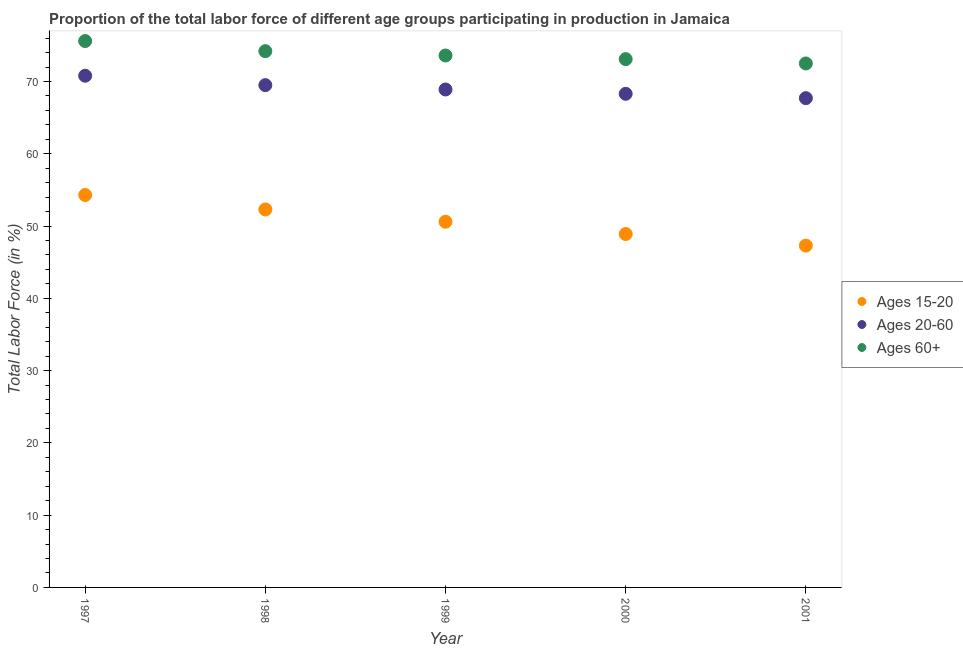How many different coloured dotlines are there?
Your answer should be compact. 3. Is the number of dotlines equal to the number of legend labels?
Offer a terse response. Yes. What is the percentage of labor force within the age group 20-60 in 1998?
Ensure brevity in your answer.  69.5. Across all years, what is the maximum percentage of labor force within the age group 15-20?
Keep it short and to the point. 54.3. Across all years, what is the minimum percentage of labor force within the age group 20-60?
Give a very brief answer. 67.7. In which year was the percentage of labor force within the age group 20-60 minimum?
Give a very brief answer. 2001. What is the total percentage of labor force within the age group 15-20 in the graph?
Your answer should be very brief. 253.4. What is the difference between the percentage of labor force within the age group 20-60 in 1997 and that in 2001?
Keep it short and to the point. 3.1. What is the difference between the percentage of labor force above age 60 in 1999 and the percentage of labor force within the age group 20-60 in 2000?
Give a very brief answer. 5.3. What is the average percentage of labor force within the age group 15-20 per year?
Give a very brief answer. 50.68. In the year 1997, what is the difference between the percentage of labor force above age 60 and percentage of labor force within the age group 15-20?
Offer a terse response. 21.3. In how many years, is the percentage of labor force above age 60 greater than 56 %?
Provide a short and direct response. 5. What is the ratio of the percentage of labor force above age 60 in 1998 to that in 2000?
Offer a very short reply. 1.02. Is the percentage of labor force within the age group 15-20 in 1998 less than that in 2000?
Ensure brevity in your answer.  No. Is the difference between the percentage of labor force above age 60 in 1998 and 1999 greater than the difference between the percentage of labor force within the age group 15-20 in 1998 and 1999?
Ensure brevity in your answer.  No. What is the difference between the highest and the lowest percentage of labor force above age 60?
Offer a very short reply. 3.1. In how many years, is the percentage of labor force within the age group 15-20 greater than the average percentage of labor force within the age group 15-20 taken over all years?
Give a very brief answer. 2. Is the sum of the percentage of labor force above age 60 in 1999 and 2000 greater than the maximum percentage of labor force within the age group 20-60 across all years?
Keep it short and to the point. Yes. Is it the case that in every year, the sum of the percentage of labor force within the age group 15-20 and percentage of labor force within the age group 20-60 is greater than the percentage of labor force above age 60?
Offer a very short reply. Yes. Does the percentage of labor force above age 60 monotonically increase over the years?
Offer a terse response. No. Is the percentage of labor force within the age group 15-20 strictly less than the percentage of labor force within the age group 20-60 over the years?
Your response must be concise. Yes. How many dotlines are there?
Offer a terse response. 3. What is the difference between two consecutive major ticks on the Y-axis?
Provide a short and direct response. 10. Are the values on the major ticks of Y-axis written in scientific E-notation?
Your response must be concise. No. Does the graph contain grids?
Provide a short and direct response. No. How many legend labels are there?
Offer a terse response. 3. What is the title of the graph?
Ensure brevity in your answer.  Proportion of the total labor force of different age groups participating in production in Jamaica. Does "Textiles and clothing" appear as one of the legend labels in the graph?
Your response must be concise. No. What is the label or title of the Y-axis?
Provide a short and direct response. Total Labor Force (in %). What is the Total Labor Force (in %) of Ages 15-20 in 1997?
Offer a terse response. 54.3. What is the Total Labor Force (in %) in Ages 20-60 in 1997?
Provide a succinct answer. 70.8. What is the Total Labor Force (in %) in Ages 60+ in 1997?
Provide a succinct answer. 75.6. What is the Total Labor Force (in %) in Ages 15-20 in 1998?
Your response must be concise. 52.3. What is the Total Labor Force (in %) in Ages 20-60 in 1998?
Your answer should be very brief. 69.5. What is the Total Labor Force (in %) of Ages 60+ in 1998?
Your answer should be compact. 74.2. What is the Total Labor Force (in %) in Ages 15-20 in 1999?
Give a very brief answer. 50.6. What is the Total Labor Force (in %) of Ages 20-60 in 1999?
Make the answer very short. 68.9. What is the Total Labor Force (in %) of Ages 60+ in 1999?
Give a very brief answer. 73.6. What is the Total Labor Force (in %) in Ages 15-20 in 2000?
Give a very brief answer. 48.9. What is the Total Labor Force (in %) in Ages 20-60 in 2000?
Your response must be concise. 68.3. What is the Total Labor Force (in %) in Ages 60+ in 2000?
Your answer should be very brief. 73.1. What is the Total Labor Force (in %) of Ages 15-20 in 2001?
Your response must be concise. 47.3. What is the Total Labor Force (in %) of Ages 20-60 in 2001?
Make the answer very short. 67.7. What is the Total Labor Force (in %) of Ages 60+ in 2001?
Provide a succinct answer. 72.5. Across all years, what is the maximum Total Labor Force (in %) in Ages 15-20?
Offer a very short reply. 54.3. Across all years, what is the maximum Total Labor Force (in %) of Ages 20-60?
Make the answer very short. 70.8. Across all years, what is the maximum Total Labor Force (in %) of Ages 60+?
Ensure brevity in your answer.  75.6. Across all years, what is the minimum Total Labor Force (in %) of Ages 15-20?
Your answer should be very brief. 47.3. Across all years, what is the minimum Total Labor Force (in %) in Ages 20-60?
Your answer should be compact. 67.7. Across all years, what is the minimum Total Labor Force (in %) in Ages 60+?
Keep it short and to the point. 72.5. What is the total Total Labor Force (in %) of Ages 15-20 in the graph?
Give a very brief answer. 253.4. What is the total Total Labor Force (in %) in Ages 20-60 in the graph?
Offer a very short reply. 345.2. What is the total Total Labor Force (in %) in Ages 60+ in the graph?
Give a very brief answer. 369. What is the difference between the Total Labor Force (in %) in Ages 15-20 in 1997 and that in 1998?
Provide a short and direct response. 2. What is the difference between the Total Labor Force (in %) in Ages 60+ in 1997 and that in 1998?
Give a very brief answer. 1.4. What is the difference between the Total Labor Force (in %) of Ages 15-20 in 1997 and that in 1999?
Keep it short and to the point. 3.7. What is the difference between the Total Labor Force (in %) in Ages 20-60 in 1997 and that in 1999?
Provide a short and direct response. 1.9. What is the difference between the Total Labor Force (in %) in Ages 60+ in 1997 and that in 1999?
Provide a succinct answer. 2. What is the difference between the Total Labor Force (in %) of Ages 20-60 in 1997 and that in 2000?
Provide a succinct answer. 2.5. What is the difference between the Total Labor Force (in %) of Ages 60+ in 1997 and that in 2000?
Make the answer very short. 2.5. What is the difference between the Total Labor Force (in %) in Ages 15-20 in 1997 and that in 2001?
Your answer should be very brief. 7. What is the difference between the Total Labor Force (in %) in Ages 60+ in 1997 and that in 2001?
Your response must be concise. 3.1. What is the difference between the Total Labor Force (in %) in Ages 15-20 in 1998 and that in 1999?
Your response must be concise. 1.7. What is the difference between the Total Labor Force (in %) in Ages 20-60 in 1998 and that in 1999?
Your response must be concise. 0.6. What is the difference between the Total Labor Force (in %) of Ages 20-60 in 1998 and that in 2000?
Offer a terse response. 1.2. What is the difference between the Total Labor Force (in %) in Ages 15-20 in 1998 and that in 2001?
Offer a terse response. 5. What is the difference between the Total Labor Force (in %) in Ages 60+ in 1999 and that in 2000?
Give a very brief answer. 0.5. What is the difference between the Total Labor Force (in %) in Ages 20-60 in 1999 and that in 2001?
Ensure brevity in your answer.  1.2. What is the difference between the Total Labor Force (in %) of Ages 60+ in 2000 and that in 2001?
Your response must be concise. 0.6. What is the difference between the Total Labor Force (in %) of Ages 15-20 in 1997 and the Total Labor Force (in %) of Ages 20-60 in 1998?
Your answer should be very brief. -15.2. What is the difference between the Total Labor Force (in %) in Ages 15-20 in 1997 and the Total Labor Force (in %) in Ages 60+ in 1998?
Provide a short and direct response. -19.9. What is the difference between the Total Labor Force (in %) in Ages 20-60 in 1997 and the Total Labor Force (in %) in Ages 60+ in 1998?
Provide a succinct answer. -3.4. What is the difference between the Total Labor Force (in %) of Ages 15-20 in 1997 and the Total Labor Force (in %) of Ages 20-60 in 1999?
Offer a terse response. -14.6. What is the difference between the Total Labor Force (in %) of Ages 15-20 in 1997 and the Total Labor Force (in %) of Ages 60+ in 1999?
Provide a short and direct response. -19.3. What is the difference between the Total Labor Force (in %) in Ages 20-60 in 1997 and the Total Labor Force (in %) in Ages 60+ in 1999?
Ensure brevity in your answer.  -2.8. What is the difference between the Total Labor Force (in %) of Ages 15-20 in 1997 and the Total Labor Force (in %) of Ages 20-60 in 2000?
Provide a succinct answer. -14. What is the difference between the Total Labor Force (in %) of Ages 15-20 in 1997 and the Total Labor Force (in %) of Ages 60+ in 2000?
Ensure brevity in your answer.  -18.8. What is the difference between the Total Labor Force (in %) of Ages 20-60 in 1997 and the Total Labor Force (in %) of Ages 60+ in 2000?
Provide a short and direct response. -2.3. What is the difference between the Total Labor Force (in %) in Ages 15-20 in 1997 and the Total Labor Force (in %) in Ages 20-60 in 2001?
Provide a short and direct response. -13.4. What is the difference between the Total Labor Force (in %) of Ages 15-20 in 1997 and the Total Labor Force (in %) of Ages 60+ in 2001?
Make the answer very short. -18.2. What is the difference between the Total Labor Force (in %) of Ages 15-20 in 1998 and the Total Labor Force (in %) of Ages 20-60 in 1999?
Offer a terse response. -16.6. What is the difference between the Total Labor Force (in %) of Ages 15-20 in 1998 and the Total Labor Force (in %) of Ages 60+ in 1999?
Offer a very short reply. -21.3. What is the difference between the Total Labor Force (in %) of Ages 15-20 in 1998 and the Total Labor Force (in %) of Ages 60+ in 2000?
Give a very brief answer. -20.8. What is the difference between the Total Labor Force (in %) of Ages 15-20 in 1998 and the Total Labor Force (in %) of Ages 20-60 in 2001?
Ensure brevity in your answer.  -15.4. What is the difference between the Total Labor Force (in %) of Ages 15-20 in 1998 and the Total Labor Force (in %) of Ages 60+ in 2001?
Provide a short and direct response. -20.2. What is the difference between the Total Labor Force (in %) in Ages 20-60 in 1998 and the Total Labor Force (in %) in Ages 60+ in 2001?
Provide a succinct answer. -3. What is the difference between the Total Labor Force (in %) in Ages 15-20 in 1999 and the Total Labor Force (in %) in Ages 20-60 in 2000?
Provide a short and direct response. -17.7. What is the difference between the Total Labor Force (in %) in Ages 15-20 in 1999 and the Total Labor Force (in %) in Ages 60+ in 2000?
Make the answer very short. -22.5. What is the difference between the Total Labor Force (in %) of Ages 20-60 in 1999 and the Total Labor Force (in %) of Ages 60+ in 2000?
Your answer should be compact. -4.2. What is the difference between the Total Labor Force (in %) of Ages 15-20 in 1999 and the Total Labor Force (in %) of Ages 20-60 in 2001?
Offer a terse response. -17.1. What is the difference between the Total Labor Force (in %) of Ages 15-20 in 1999 and the Total Labor Force (in %) of Ages 60+ in 2001?
Provide a succinct answer. -21.9. What is the difference between the Total Labor Force (in %) of Ages 20-60 in 1999 and the Total Labor Force (in %) of Ages 60+ in 2001?
Provide a short and direct response. -3.6. What is the difference between the Total Labor Force (in %) of Ages 15-20 in 2000 and the Total Labor Force (in %) of Ages 20-60 in 2001?
Keep it short and to the point. -18.8. What is the difference between the Total Labor Force (in %) of Ages 15-20 in 2000 and the Total Labor Force (in %) of Ages 60+ in 2001?
Provide a short and direct response. -23.6. What is the average Total Labor Force (in %) of Ages 15-20 per year?
Provide a succinct answer. 50.68. What is the average Total Labor Force (in %) in Ages 20-60 per year?
Your answer should be compact. 69.04. What is the average Total Labor Force (in %) in Ages 60+ per year?
Make the answer very short. 73.8. In the year 1997, what is the difference between the Total Labor Force (in %) in Ages 15-20 and Total Labor Force (in %) in Ages 20-60?
Keep it short and to the point. -16.5. In the year 1997, what is the difference between the Total Labor Force (in %) in Ages 15-20 and Total Labor Force (in %) in Ages 60+?
Your answer should be compact. -21.3. In the year 1997, what is the difference between the Total Labor Force (in %) of Ages 20-60 and Total Labor Force (in %) of Ages 60+?
Your answer should be compact. -4.8. In the year 1998, what is the difference between the Total Labor Force (in %) of Ages 15-20 and Total Labor Force (in %) of Ages 20-60?
Make the answer very short. -17.2. In the year 1998, what is the difference between the Total Labor Force (in %) of Ages 15-20 and Total Labor Force (in %) of Ages 60+?
Offer a very short reply. -21.9. In the year 1998, what is the difference between the Total Labor Force (in %) in Ages 20-60 and Total Labor Force (in %) in Ages 60+?
Offer a terse response. -4.7. In the year 1999, what is the difference between the Total Labor Force (in %) of Ages 15-20 and Total Labor Force (in %) of Ages 20-60?
Ensure brevity in your answer.  -18.3. In the year 1999, what is the difference between the Total Labor Force (in %) in Ages 20-60 and Total Labor Force (in %) in Ages 60+?
Keep it short and to the point. -4.7. In the year 2000, what is the difference between the Total Labor Force (in %) in Ages 15-20 and Total Labor Force (in %) in Ages 20-60?
Give a very brief answer. -19.4. In the year 2000, what is the difference between the Total Labor Force (in %) of Ages 15-20 and Total Labor Force (in %) of Ages 60+?
Keep it short and to the point. -24.2. In the year 2000, what is the difference between the Total Labor Force (in %) of Ages 20-60 and Total Labor Force (in %) of Ages 60+?
Offer a terse response. -4.8. In the year 2001, what is the difference between the Total Labor Force (in %) in Ages 15-20 and Total Labor Force (in %) in Ages 20-60?
Offer a terse response. -20.4. In the year 2001, what is the difference between the Total Labor Force (in %) of Ages 15-20 and Total Labor Force (in %) of Ages 60+?
Keep it short and to the point. -25.2. What is the ratio of the Total Labor Force (in %) of Ages 15-20 in 1997 to that in 1998?
Provide a succinct answer. 1.04. What is the ratio of the Total Labor Force (in %) of Ages 20-60 in 1997 to that in 1998?
Offer a very short reply. 1.02. What is the ratio of the Total Labor Force (in %) in Ages 60+ in 1997 to that in 1998?
Ensure brevity in your answer.  1.02. What is the ratio of the Total Labor Force (in %) of Ages 15-20 in 1997 to that in 1999?
Provide a short and direct response. 1.07. What is the ratio of the Total Labor Force (in %) of Ages 20-60 in 1997 to that in 1999?
Your response must be concise. 1.03. What is the ratio of the Total Labor Force (in %) in Ages 60+ in 1997 to that in 1999?
Your answer should be very brief. 1.03. What is the ratio of the Total Labor Force (in %) in Ages 15-20 in 1997 to that in 2000?
Keep it short and to the point. 1.11. What is the ratio of the Total Labor Force (in %) in Ages 20-60 in 1997 to that in 2000?
Provide a succinct answer. 1.04. What is the ratio of the Total Labor Force (in %) in Ages 60+ in 1997 to that in 2000?
Offer a very short reply. 1.03. What is the ratio of the Total Labor Force (in %) in Ages 15-20 in 1997 to that in 2001?
Your answer should be very brief. 1.15. What is the ratio of the Total Labor Force (in %) in Ages 20-60 in 1997 to that in 2001?
Keep it short and to the point. 1.05. What is the ratio of the Total Labor Force (in %) of Ages 60+ in 1997 to that in 2001?
Your answer should be compact. 1.04. What is the ratio of the Total Labor Force (in %) in Ages 15-20 in 1998 to that in 1999?
Ensure brevity in your answer.  1.03. What is the ratio of the Total Labor Force (in %) of Ages 20-60 in 1998 to that in 1999?
Make the answer very short. 1.01. What is the ratio of the Total Labor Force (in %) in Ages 60+ in 1998 to that in 1999?
Provide a succinct answer. 1.01. What is the ratio of the Total Labor Force (in %) in Ages 15-20 in 1998 to that in 2000?
Ensure brevity in your answer.  1.07. What is the ratio of the Total Labor Force (in %) in Ages 20-60 in 1998 to that in 2000?
Offer a very short reply. 1.02. What is the ratio of the Total Labor Force (in %) of Ages 15-20 in 1998 to that in 2001?
Your response must be concise. 1.11. What is the ratio of the Total Labor Force (in %) in Ages 20-60 in 1998 to that in 2001?
Your answer should be compact. 1.03. What is the ratio of the Total Labor Force (in %) in Ages 60+ in 1998 to that in 2001?
Your answer should be compact. 1.02. What is the ratio of the Total Labor Force (in %) of Ages 15-20 in 1999 to that in 2000?
Your answer should be very brief. 1.03. What is the ratio of the Total Labor Force (in %) of Ages 20-60 in 1999 to that in 2000?
Your answer should be compact. 1.01. What is the ratio of the Total Labor Force (in %) in Ages 60+ in 1999 to that in 2000?
Provide a short and direct response. 1.01. What is the ratio of the Total Labor Force (in %) of Ages 15-20 in 1999 to that in 2001?
Offer a very short reply. 1.07. What is the ratio of the Total Labor Force (in %) of Ages 20-60 in 1999 to that in 2001?
Offer a very short reply. 1.02. What is the ratio of the Total Labor Force (in %) in Ages 60+ in 1999 to that in 2001?
Provide a succinct answer. 1.02. What is the ratio of the Total Labor Force (in %) of Ages 15-20 in 2000 to that in 2001?
Provide a short and direct response. 1.03. What is the ratio of the Total Labor Force (in %) of Ages 20-60 in 2000 to that in 2001?
Keep it short and to the point. 1.01. What is the ratio of the Total Labor Force (in %) in Ages 60+ in 2000 to that in 2001?
Your response must be concise. 1.01. What is the difference between the highest and the second highest Total Labor Force (in %) of Ages 15-20?
Provide a short and direct response. 2. What is the difference between the highest and the second highest Total Labor Force (in %) of Ages 20-60?
Provide a succinct answer. 1.3. What is the difference between the highest and the second highest Total Labor Force (in %) in Ages 60+?
Offer a very short reply. 1.4. What is the difference between the highest and the lowest Total Labor Force (in %) in Ages 15-20?
Your answer should be very brief. 7. What is the difference between the highest and the lowest Total Labor Force (in %) of Ages 20-60?
Make the answer very short. 3.1. What is the difference between the highest and the lowest Total Labor Force (in %) in Ages 60+?
Ensure brevity in your answer.  3.1. 